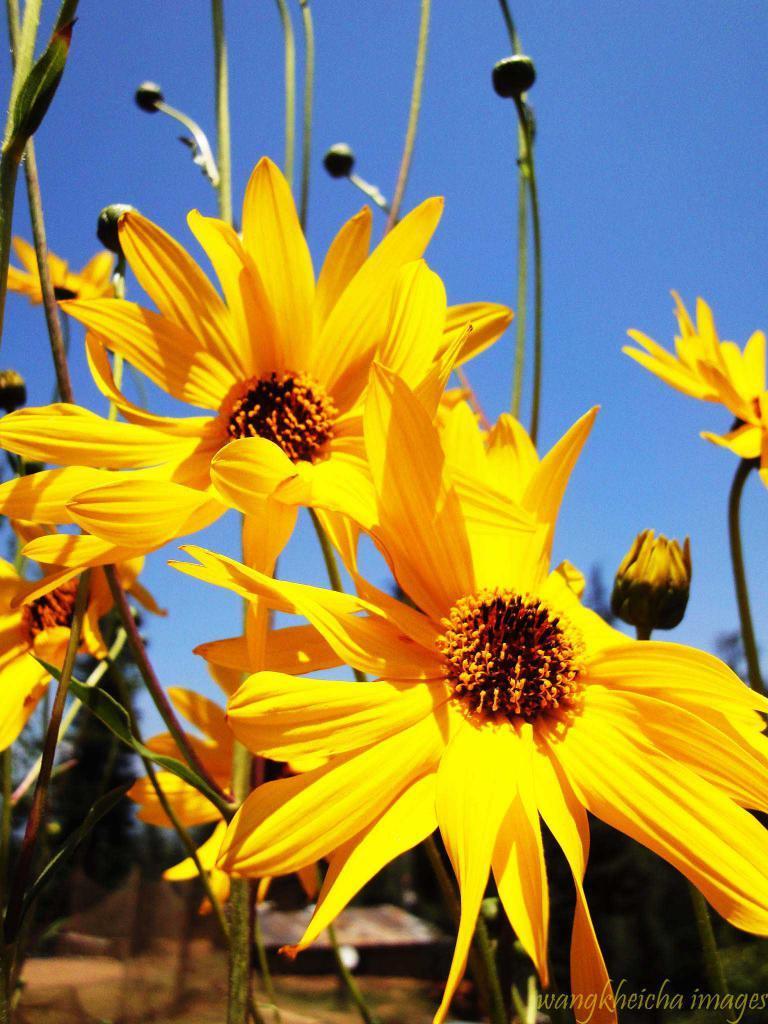How would you summarize this image in a sentence or two? In this picture I can see flowers and buds, and in the background there is the sky and there is a watermark on the image. 